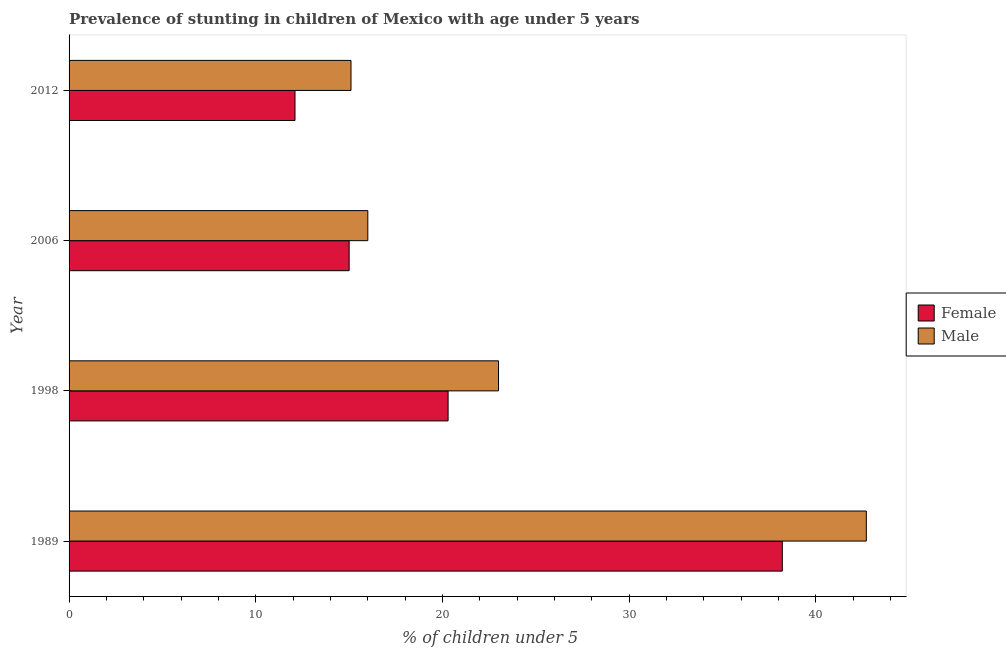Are the number of bars per tick equal to the number of legend labels?
Provide a succinct answer. Yes. Are the number of bars on each tick of the Y-axis equal?
Your response must be concise. Yes. How many bars are there on the 4th tick from the top?
Provide a short and direct response. 2. What is the percentage of stunted male children in 1989?
Offer a terse response. 42.7. Across all years, what is the maximum percentage of stunted female children?
Give a very brief answer. 38.2. Across all years, what is the minimum percentage of stunted female children?
Give a very brief answer. 12.1. In which year was the percentage of stunted female children minimum?
Your response must be concise. 2012. What is the total percentage of stunted female children in the graph?
Your answer should be compact. 85.6. What is the difference between the percentage of stunted male children in 1989 and that in 2006?
Provide a short and direct response. 26.7. What is the difference between the percentage of stunted male children in 1989 and the percentage of stunted female children in 2012?
Your answer should be compact. 30.6. What is the average percentage of stunted male children per year?
Ensure brevity in your answer.  24.2. In the year 2012, what is the difference between the percentage of stunted female children and percentage of stunted male children?
Provide a short and direct response. -3. What is the ratio of the percentage of stunted female children in 2006 to that in 2012?
Your response must be concise. 1.24. Is the difference between the percentage of stunted male children in 1989 and 2006 greater than the difference between the percentage of stunted female children in 1989 and 2006?
Give a very brief answer. Yes. What is the difference between the highest and the second highest percentage of stunted male children?
Your answer should be compact. 19.7. What is the difference between the highest and the lowest percentage of stunted female children?
Provide a short and direct response. 26.1. What does the 1st bar from the top in 1998 represents?
Keep it short and to the point. Male. What does the 1st bar from the bottom in 2012 represents?
Give a very brief answer. Female. How many bars are there?
Offer a very short reply. 8. How many years are there in the graph?
Make the answer very short. 4. What is the difference between two consecutive major ticks on the X-axis?
Keep it short and to the point. 10. Does the graph contain any zero values?
Keep it short and to the point. No. Does the graph contain grids?
Ensure brevity in your answer.  No. Where does the legend appear in the graph?
Ensure brevity in your answer.  Center right. How many legend labels are there?
Your answer should be very brief. 2. How are the legend labels stacked?
Keep it short and to the point. Vertical. What is the title of the graph?
Offer a terse response. Prevalence of stunting in children of Mexico with age under 5 years. What is the label or title of the X-axis?
Your response must be concise.  % of children under 5. What is the label or title of the Y-axis?
Give a very brief answer. Year. What is the  % of children under 5 in Female in 1989?
Your answer should be compact. 38.2. What is the  % of children under 5 of Male in 1989?
Provide a short and direct response. 42.7. What is the  % of children under 5 in Female in 1998?
Your response must be concise. 20.3. What is the  % of children under 5 in Female in 2006?
Give a very brief answer. 15. What is the  % of children under 5 of Female in 2012?
Ensure brevity in your answer.  12.1. What is the  % of children under 5 in Male in 2012?
Give a very brief answer. 15.1. Across all years, what is the maximum  % of children under 5 of Female?
Provide a succinct answer. 38.2. Across all years, what is the maximum  % of children under 5 in Male?
Your response must be concise. 42.7. Across all years, what is the minimum  % of children under 5 in Female?
Make the answer very short. 12.1. Across all years, what is the minimum  % of children under 5 of Male?
Keep it short and to the point. 15.1. What is the total  % of children under 5 in Female in the graph?
Offer a terse response. 85.6. What is the total  % of children under 5 of Male in the graph?
Make the answer very short. 96.8. What is the difference between the  % of children under 5 of Female in 1989 and that in 2006?
Your answer should be very brief. 23.2. What is the difference between the  % of children under 5 in Male in 1989 and that in 2006?
Your answer should be compact. 26.7. What is the difference between the  % of children under 5 of Female in 1989 and that in 2012?
Give a very brief answer. 26.1. What is the difference between the  % of children under 5 of Male in 1989 and that in 2012?
Your answer should be compact. 27.6. What is the difference between the  % of children under 5 in Female in 1998 and that in 2006?
Keep it short and to the point. 5.3. What is the difference between the  % of children under 5 in Male in 1998 and that in 2006?
Give a very brief answer. 7. What is the difference between the  % of children under 5 of Female in 1998 and that in 2012?
Make the answer very short. 8.2. What is the difference between the  % of children under 5 in Male in 1998 and that in 2012?
Offer a very short reply. 7.9. What is the difference between the  % of children under 5 of Female in 2006 and that in 2012?
Give a very brief answer. 2.9. What is the difference between the  % of children under 5 of Male in 2006 and that in 2012?
Provide a short and direct response. 0.9. What is the difference between the  % of children under 5 of Female in 1989 and the  % of children under 5 of Male in 2012?
Your answer should be compact. 23.1. What is the difference between the  % of children under 5 in Female in 2006 and the  % of children under 5 in Male in 2012?
Give a very brief answer. -0.1. What is the average  % of children under 5 in Female per year?
Your answer should be very brief. 21.4. What is the average  % of children under 5 in Male per year?
Your response must be concise. 24.2. In the year 1989, what is the difference between the  % of children under 5 of Female and  % of children under 5 of Male?
Make the answer very short. -4.5. In the year 2012, what is the difference between the  % of children under 5 in Female and  % of children under 5 in Male?
Provide a short and direct response. -3. What is the ratio of the  % of children under 5 of Female in 1989 to that in 1998?
Keep it short and to the point. 1.88. What is the ratio of the  % of children under 5 in Male in 1989 to that in 1998?
Give a very brief answer. 1.86. What is the ratio of the  % of children under 5 of Female in 1989 to that in 2006?
Your answer should be very brief. 2.55. What is the ratio of the  % of children under 5 of Male in 1989 to that in 2006?
Provide a succinct answer. 2.67. What is the ratio of the  % of children under 5 in Female in 1989 to that in 2012?
Keep it short and to the point. 3.16. What is the ratio of the  % of children under 5 in Male in 1989 to that in 2012?
Provide a short and direct response. 2.83. What is the ratio of the  % of children under 5 in Female in 1998 to that in 2006?
Make the answer very short. 1.35. What is the ratio of the  % of children under 5 in Male in 1998 to that in 2006?
Give a very brief answer. 1.44. What is the ratio of the  % of children under 5 in Female in 1998 to that in 2012?
Keep it short and to the point. 1.68. What is the ratio of the  % of children under 5 of Male in 1998 to that in 2012?
Your answer should be compact. 1.52. What is the ratio of the  % of children under 5 of Female in 2006 to that in 2012?
Make the answer very short. 1.24. What is the ratio of the  % of children under 5 of Male in 2006 to that in 2012?
Keep it short and to the point. 1.06. What is the difference between the highest and the second highest  % of children under 5 of Male?
Offer a very short reply. 19.7. What is the difference between the highest and the lowest  % of children under 5 of Female?
Your answer should be compact. 26.1. What is the difference between the highest and the lowest  % of children under 5 in Male?
Keep it short and to the point. 27.6. 